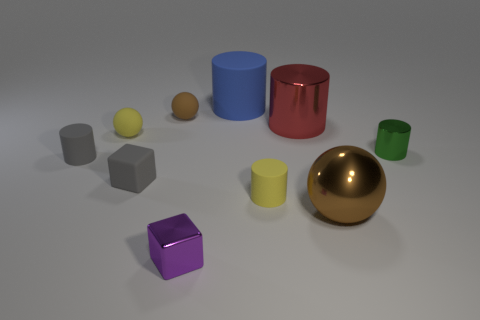Do the metal object behind the small metal cylinder and the brown thing that is right of the purple metal thing have the same size?
Offer a very short reply. Yes. Is there anything else that is the same material as the yellow cylinder?
Your response must be concise. Yes. What number of things are either things in front of the red thing or cylinders that are behind the brown matte thing?
Make the answer very short. 8. Does the small green thing have the same material as the sphere in front of the small rubber cube?
Provide a short and direct response. Yes. What shape is the thing that is in front of the small gray cube and behind the large ball?
Give a very brief answer. Cylinder. How many other things are the same color as the large metal ball?
Keep it short and to the point. 1. What shape is the brown metallic thing?
Your answer should be very brief. Sphere. The large object in front of the small yellow thing that is right of the small shiny cube is what color?
Keep it short and to the point. Brown. Does the small rubber block have the same color as the tiny matte cylinder that is left of the matte cube?
Provide a succinct answer. Yes. What is the tiny cylinder that is behind the tiny yellow cylinder and on the left side of the large red metal object made of?
Offer a very short reply. Rubber. 